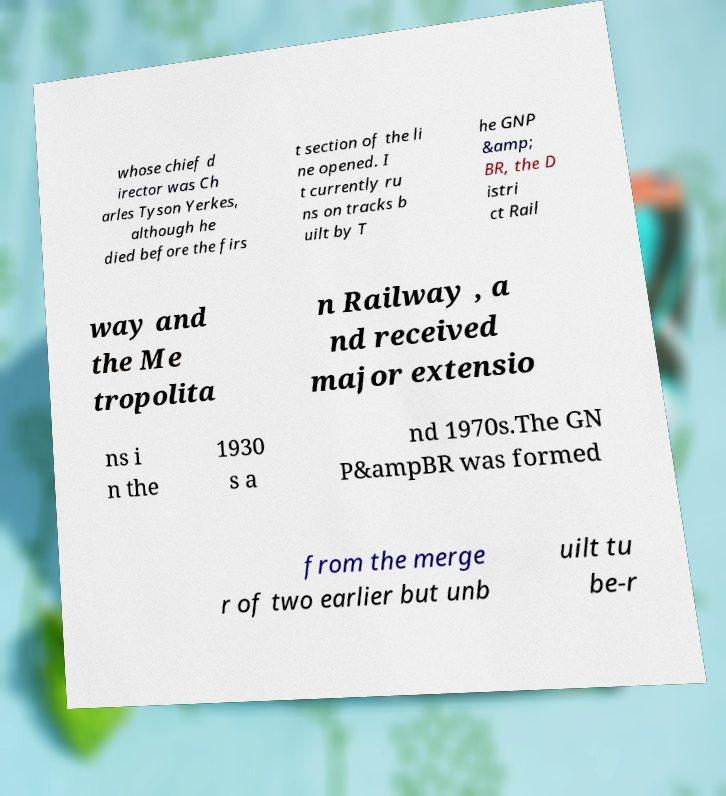Can you accurately transcribe the text from the provided image for me? whose chief d irector was Ch arles Tyson Yerkes, although he died before the firs t section of the li ne opened. I t currently ru ns on tracks b uilt by T he GNP &amp; BR, the D istri ct Rail way and the Me tropolita n Railway , a nd received major extensio ns i n the 1930 s a nd 1970s.The GN P&ampBR was formed from the merge r of two earlier but unb uilt tu be-r 